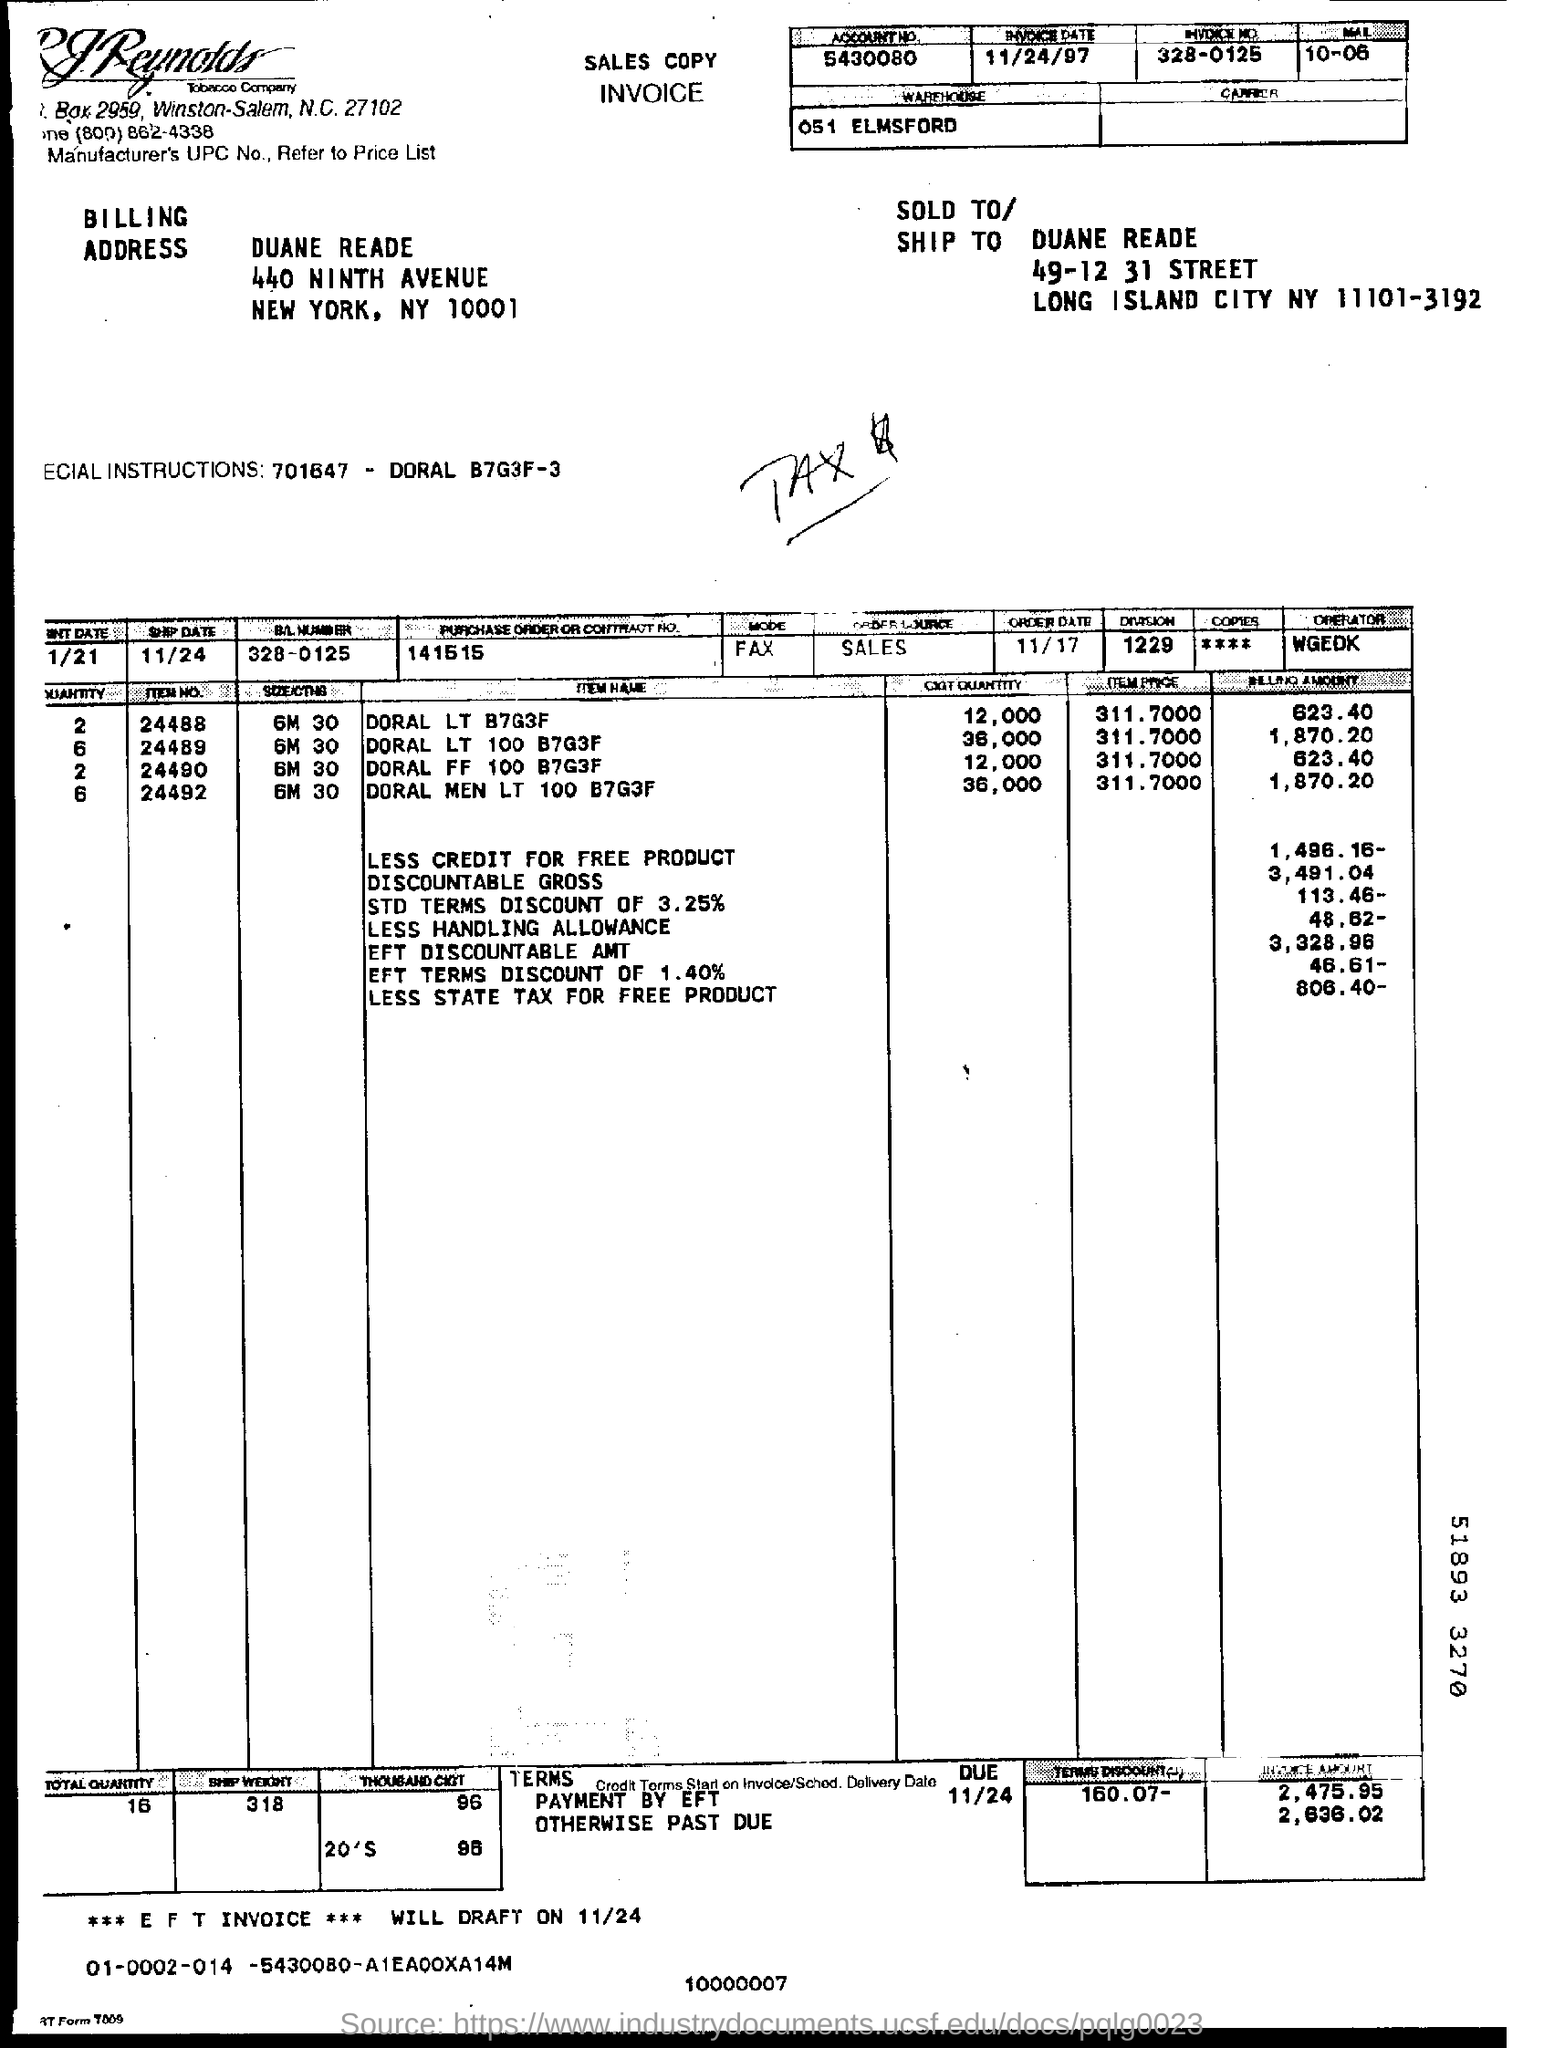What type of document is this?
Provide a short and direct response. INVOICE. Which city name is mentioned in BILLING ADDRESS?
Your answer should be compact. NEW YORK. Which city name is mentioned in "SOLD TO/SHIP TO" adresss given?
Keep it short and to the point. LONG ISLAND CITY. What is the ZIP code mentioned in BILLING ADDRESS?
Keep it short and to the point. NY 10001. What is the street name mentioned in "SOLD TO/SHIP TO" adresss?
Provide a succinct answer. 49-12 31 STREET. What is the PURCHASE ORDER OR CONTRACT NO given at the top of the table?
Offer a terse response. 141515. What is the ORDER DATE given at the top of the table?
Your answer should be very brief. 11/17. What is the "TOTAL QUANTITY" given at the left bottom of the invoice?
Provide a succinct answer. 16. Mention the "DUE" date given ?
Your answer should be compact. 11/24. What is the "INVOICE AMOUNT" payment by EFT within DUE date?
Your answer should be very brief. 2,475.95. What is the "INVOICE AMOUNT" payment PAST DUE date?
Give a very brief answer. 2,636.02. 